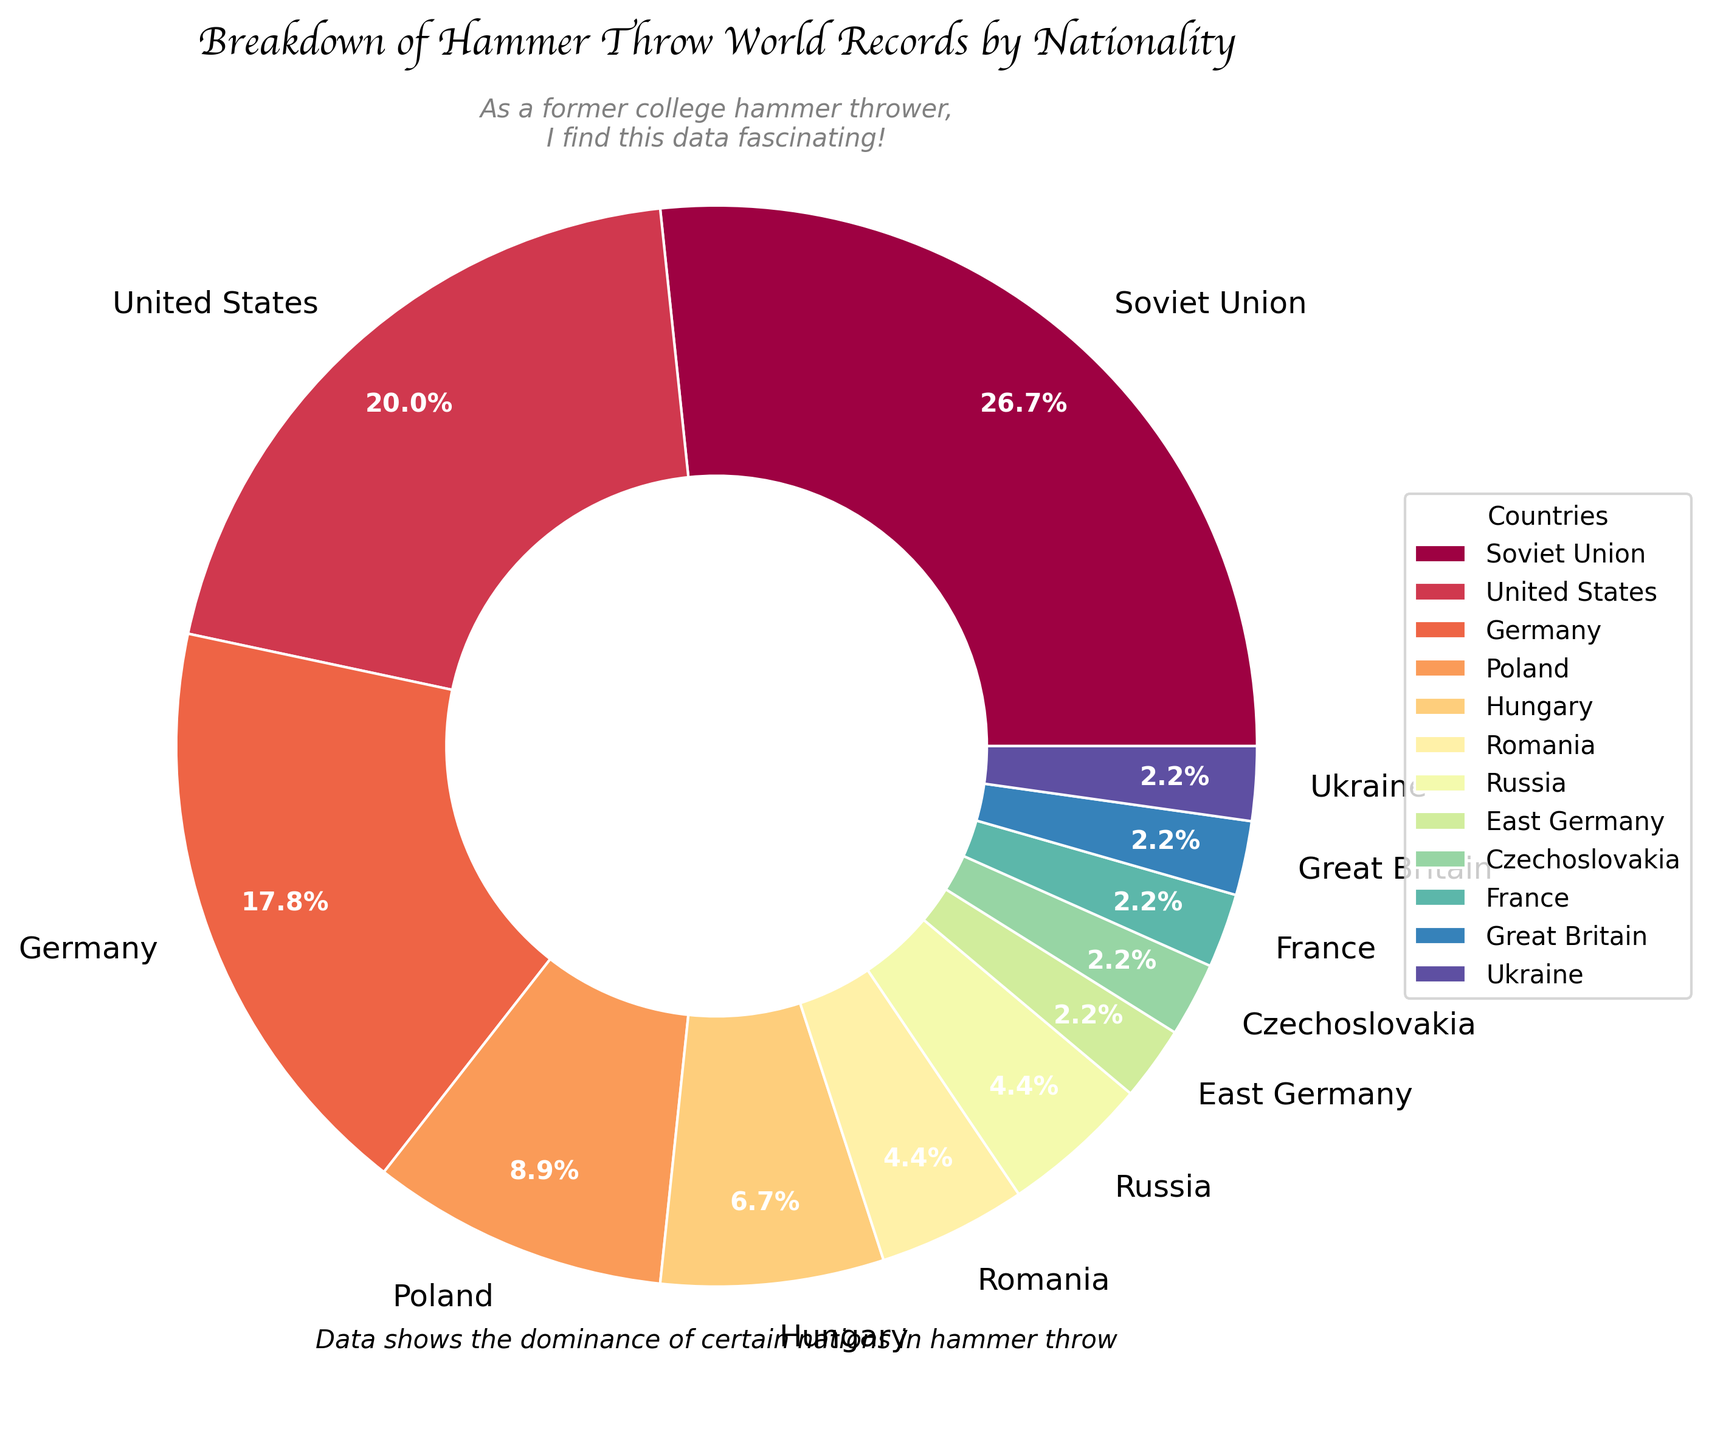What percentage of the total world records are held by the Soviet Union? The Soviet Union holds 12 world records out of a total sum of 44 world records. The percentage is calculated by (12/44) * 100.
Answer: 27.3% Which country holds the second-highest number of world records? The United States holds the second-highest number of world records with 9 records, as can be seen from the pie chart's distribution.
Answer: United States How many world records are held by European countries in the pie chart? Summing the records held by Germany, Poland, Hungary, Romania, Russia, East Germany, Czechoslovakia, France, Great Britain, and Ukraine gives 8+4+3+2+2+1+1+1+1+1 = 24 records.
Answer: 24 Is the combined number of records held by Germany and the United States greater than that of the Soviet Union? Germany holds 8 records and the United States holds 9, which together sum up to 17. The Soviet Union holds 12 records, so 17 is greater than 12.
Answer: Yes Which country has the least number of world records, and what is the number? The countries East Germany, Czechoslovakia, France, Great Britain, and Ukraine each hold the least with 1 record apiece, based on their portions in the pie chart.
Answer: East Germany, Czechoslovakia, France, Great Britain, Ukraine; 1 each What is the percentage difference between the total number of world records held by the United States and those held by Poland? The United States holds 9 records, and Poland holds 4. The difference is 5 records. The percentage difference is (5 / 44) * 100.
Answer: 11.4% Are the number of records held by Russia and Romania combined greater than those held by Hungary? Russia and Romania together hold 2+2 = 4 records. Hungary holds 3 records, so 4 is greater than 3.
Answer: Yes What percentage of the total records are held by countries that have 3 records or fewer? Summing the records held by Hungary (3), Romania (2), Russia (2), East Germany (1), Czechoslovakia (1), France (1), Great Britain (1), and Ukraine (1) gives 3+2+2+1+1+1+1+1 = 12 records. The percentage is (12 / 44) * 100.
Answer: 27.3% Which other country besides Germany and the Soviet Union has held more than 5 world records? The United States holds 9 world records, more than 5, as shown by its segment in the pie chart.
Answer: United States 